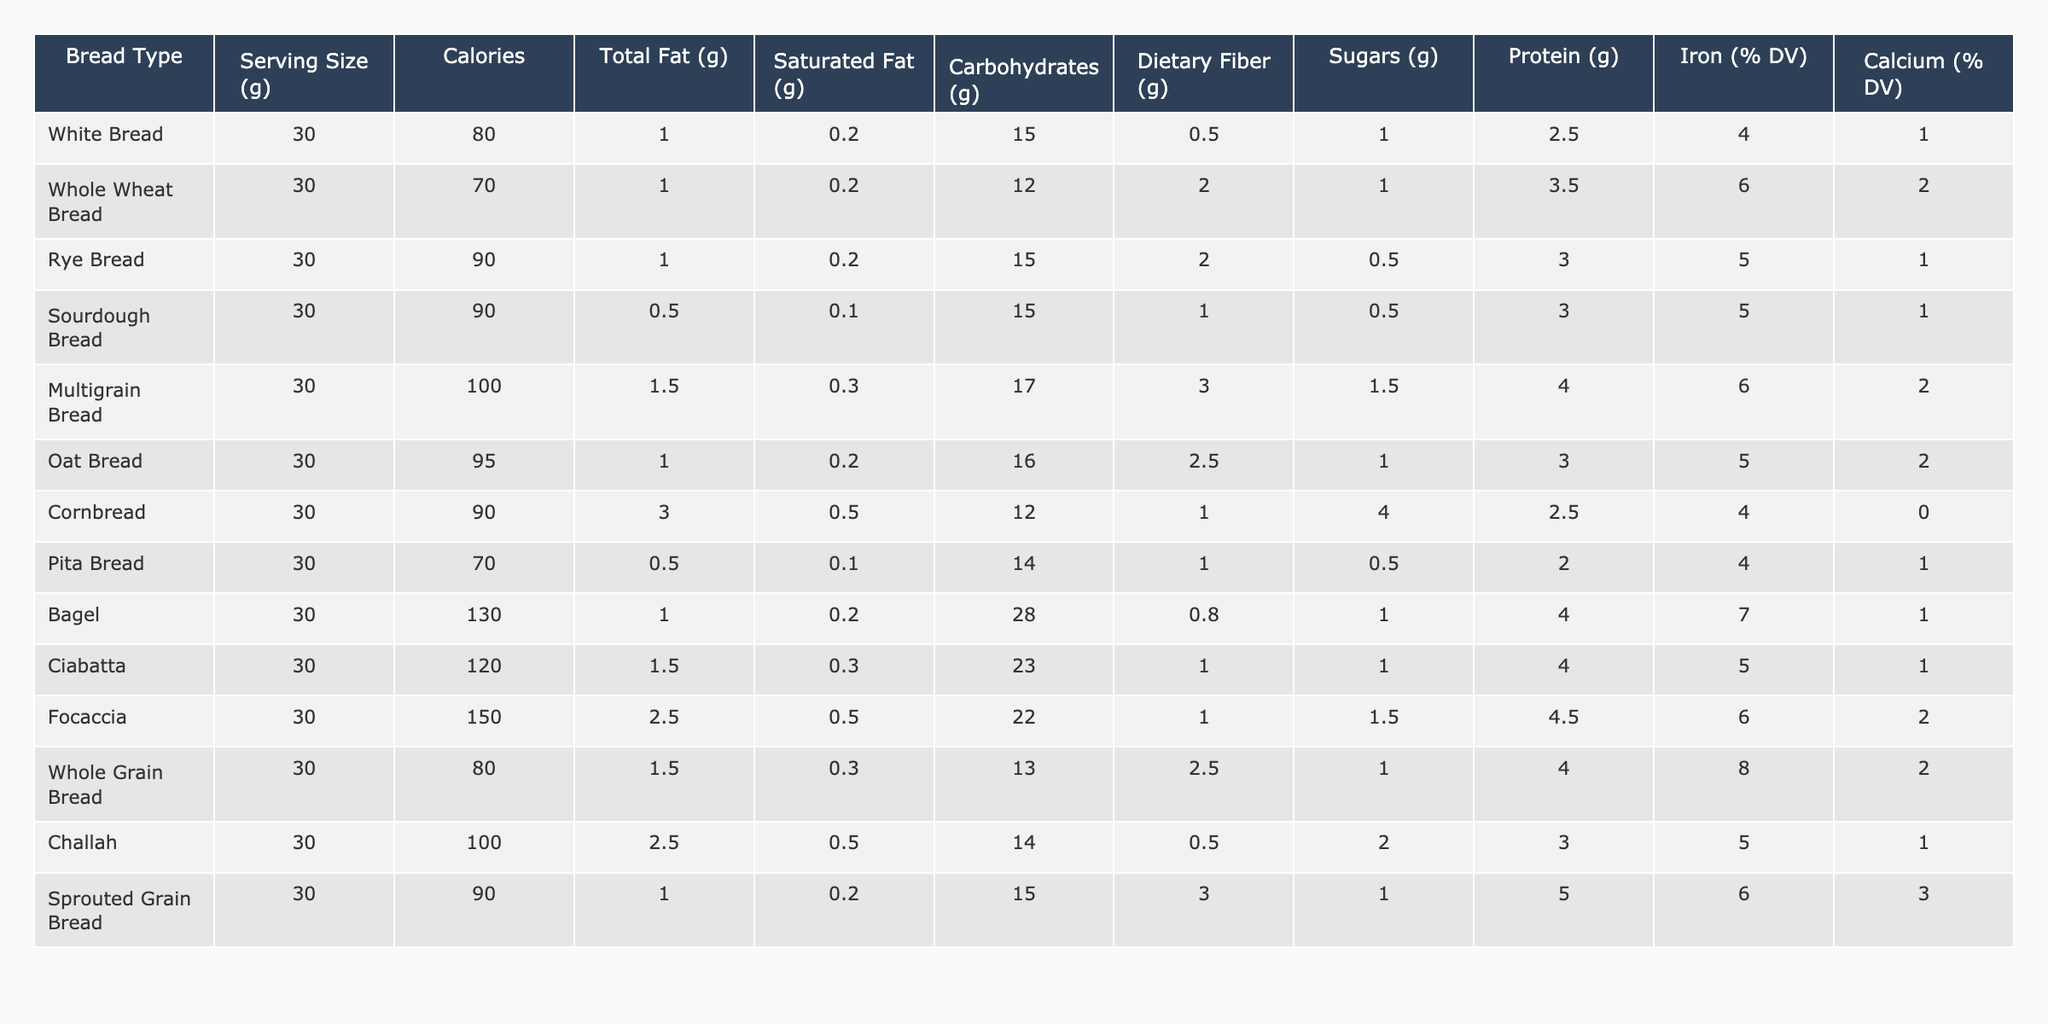What is the calorie content of Whole Wheat Bread? The table shows that Whole Wheat Bread has a calorie content of 70 calories per 30g serving.
Answer: 70 How much dietary fiber is present in Multigrain Bread? According to the table, Multigrain Bread has 3.0g of dietary fiber per 30g serving.
Answer: 3.0g Which bread type has the highest protein content? By examining the protein values in the table, we see that Sprouted Grain Bread has the highest protein content at 5.0g per serving.
Answer: Sprouted Grain Bread Is the saturated fat content in Sourdough Bread less than in Cornbread? Comparing the saturated fat values, Sourdough Bread has 0.1g while Cornbread has 0.5g, thus Sourdough has less saturated fat.
Answer: Yes What is the total carbohydrate content in Rye Bread compared to Whole Wheat Bread? Rye Bread has 15.0g of carbohydrates and Whole Wheat Bread has 12.0g, so Rye Bread has more carbohydrates.
Answer: Rye Bread has more carbohydrates Which bread has the lowest calorie count? Looking through the calorie values, Whole Wheat Bread has the lowest at 70 calories per serving.
Answer: Whole Wheat Bread Calculating the average calories for the bread types listed, what is the result? The total calorie count is 80 + 70 + 90 + 90 + 100 + 95 + 90 + 70 + 130 + 120 + 150 + 80 + 100 + 90 = 1315 calories; there are 14 types of bread, so the average is 1315 / 14 ≈ 93.9.
Answer: 93.9 True or False: Pita Bread has more sugars than Oat Bread. The table indicates Pita Bread has 0.5g of sugars while Oat Bread has 1.0g, which shows Oat Bread has more sugars.
Answer: False What is the difference in iron percentage between Bagel and Ciabatta? Bagel has 7% DV of iron and Ciabatta has 5% DV, so the difference is 7% - 5% = 2%.
Answer: 2% Which type of bread offers the least amount of total fat? From the table, Pita Bread has the least total fat content at 0.5g per serving.
Answer: Pita Bread 